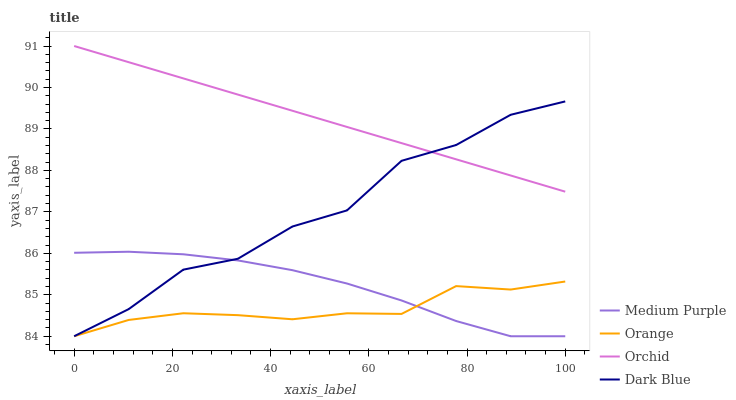Does Orange have the minimum area under the curve?
Answer yes or no. Yes. Does Orchid have the maximum area under the curve?
Answer yes or no. Yes. Does Dark Blue have the minimum area under the curve?
Answer yes or no. No. Does Dark Blue have the maximum area under the curve?
Answer yes or no. No. Is Orchid the smoothest?
Answer yes or no. Yes. Is Dark Blue the roughest?
Answer yes or no. Yes. Is Orange the smoothest?
Answer yes or no. No. Is Orange the roughest?
Answer yes or no. No. Does Medium Purple have the lowest value?
Answer yes or no. Yes. Does Orchid have the lowest value?
Answer yes or no. No. Does Orchid have the highest value?
Answer yes or no. Yes. Does Dark Blue have the highest value?
Answer yes or no. No. Is Medium Purple less than Orchid?
Answer yes or no. Yes. Is Orchid greater than Medium Purple?
Answer yes or no. Yes. Does Orchid intersect Dark Blue?
Answer yes or no. Yes. Is Orchid less than Dark Blue?
Answer yes or no. No. Is Orchid greater than Dark Blue?
Answer yes or no. No. Does Medium Purple intersect Orchid?
Answer yes or no. No. 